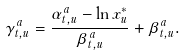Convert formula to latex. <formula><loc_0><loc_0><loc_500><loc_500>\gamma ^ { a } _ { t , u } = \frac { \alpha ^ { a } _ { t , u } - \ln { x ^ { * } _ { u } } } { \beta ^ { a } _ { t , u } } + \beta ^ { a } _ { t , u } .</formula> 